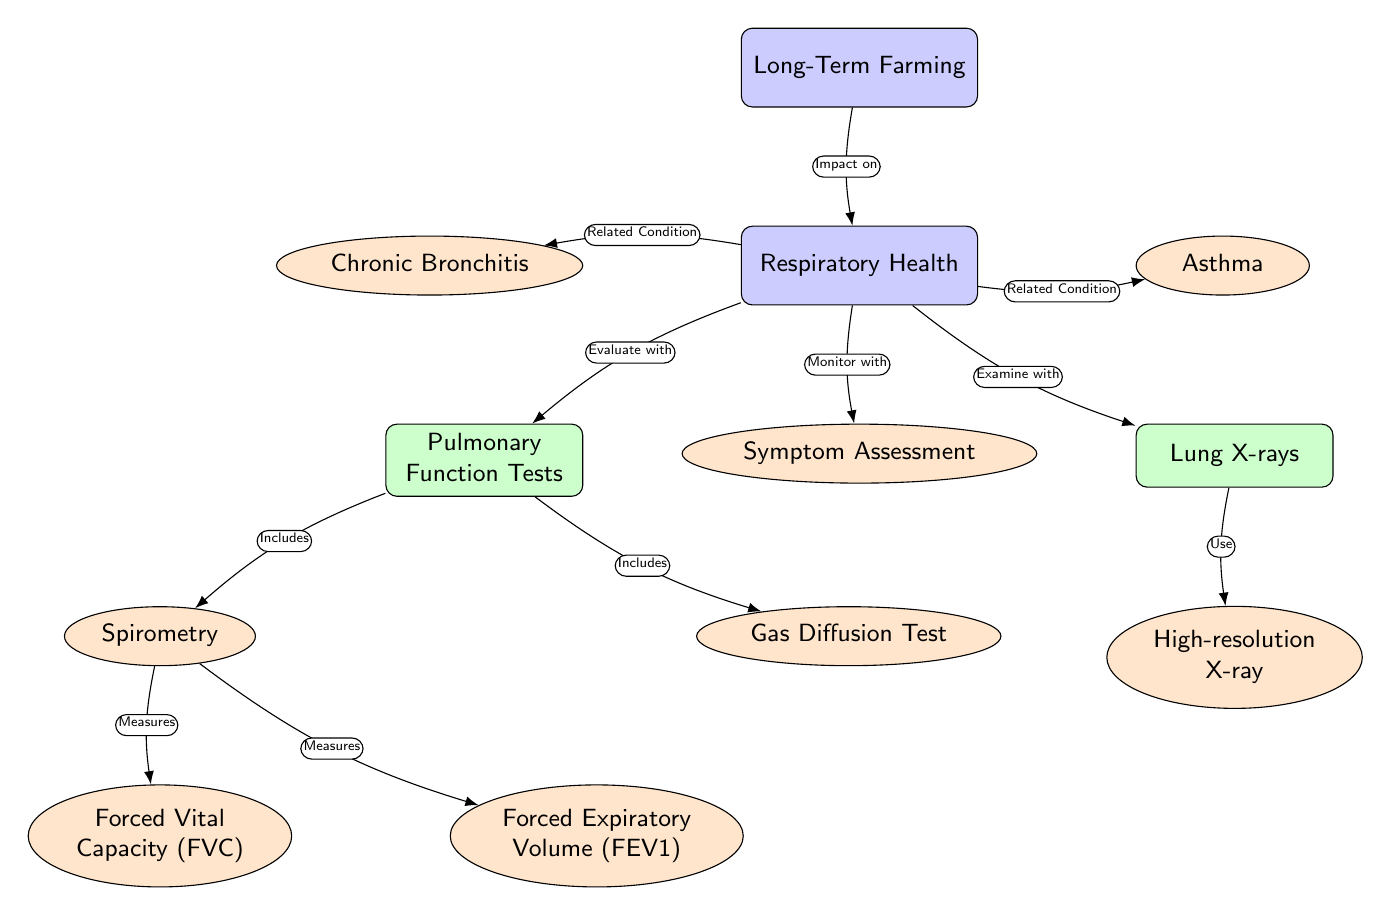What is the main focus of the diagram? The diagram highlights the relationship between Long-Term Farming and its impacts on Respiratory Health. The main node labeled "Long-Term Farming" is directly connected to the main node labeled "Respiratory Health", indicating their focus.
Answer: Respiratory Health How many sub-nodes are connected to Respiratory Health? The diagram shows two sub-nodes connected to "Respiratory Health": "Pulmonary Function Tests" and "Lung X-rays". Therefore, the total count of sub-nodes connected to Respiratory Health is two.
Answer: 2 What are the two conditions related to Respiratory Health? The diagram outlines two related conditions to "Respiratory Health", which are represented as leaf nodes: "Chronic Bronchitis" and "Asthma".
Answer: Chronic Bronchitis, Asthma Which test includes Forced Vital Capacity (FVC)? The node "Spirometry" under "Pulmonary Function Tests" includes the measurement of "Forced Vital Capacity (FVC)", as indicated by the connecting edge in the diagram.
Answer: Spirometry How does Long-Term Farming impact Respiratory Health? The diagram indicates that "Long-Term Farming" has an impact on "Respiratory Health" through a direct edge, showing a causal relationship from farming to health.
Answer: Impact on What does the "Gas Diffusion Test" measure? The "Gas Diffusion Test," which is a part of the "Pulmonary Function Tests," measures the efficiency of gas transfer in the lungs, as denoted in the diagram.
Answer: Measures gas transfer What type of X-ray is used in assessing respiratory health? The sub-node "High-resolution X-ray" is specifically mentioned under "Lung X-rays", indicating its use in the assessment of respiratory conditions.
Answer: High-resolution X-ray What is evaluated with Pulmonary Function Tests? The diagram indicates that "Respiratory Health" is evaluated with "Pulmonary Function Tests", making it clear that these tests are designed to measure pulmonary function and assess health.
Answer: Respiratory Health How many measurement types are included in Spirometry? The diagram shows that "Spirometry" includes two measurement types: "Forced Vital Capacity (FVC)" and "Forced Expiratory Volume (FEV1)". Thus, there are two measurement types shown.
Answer: 2 